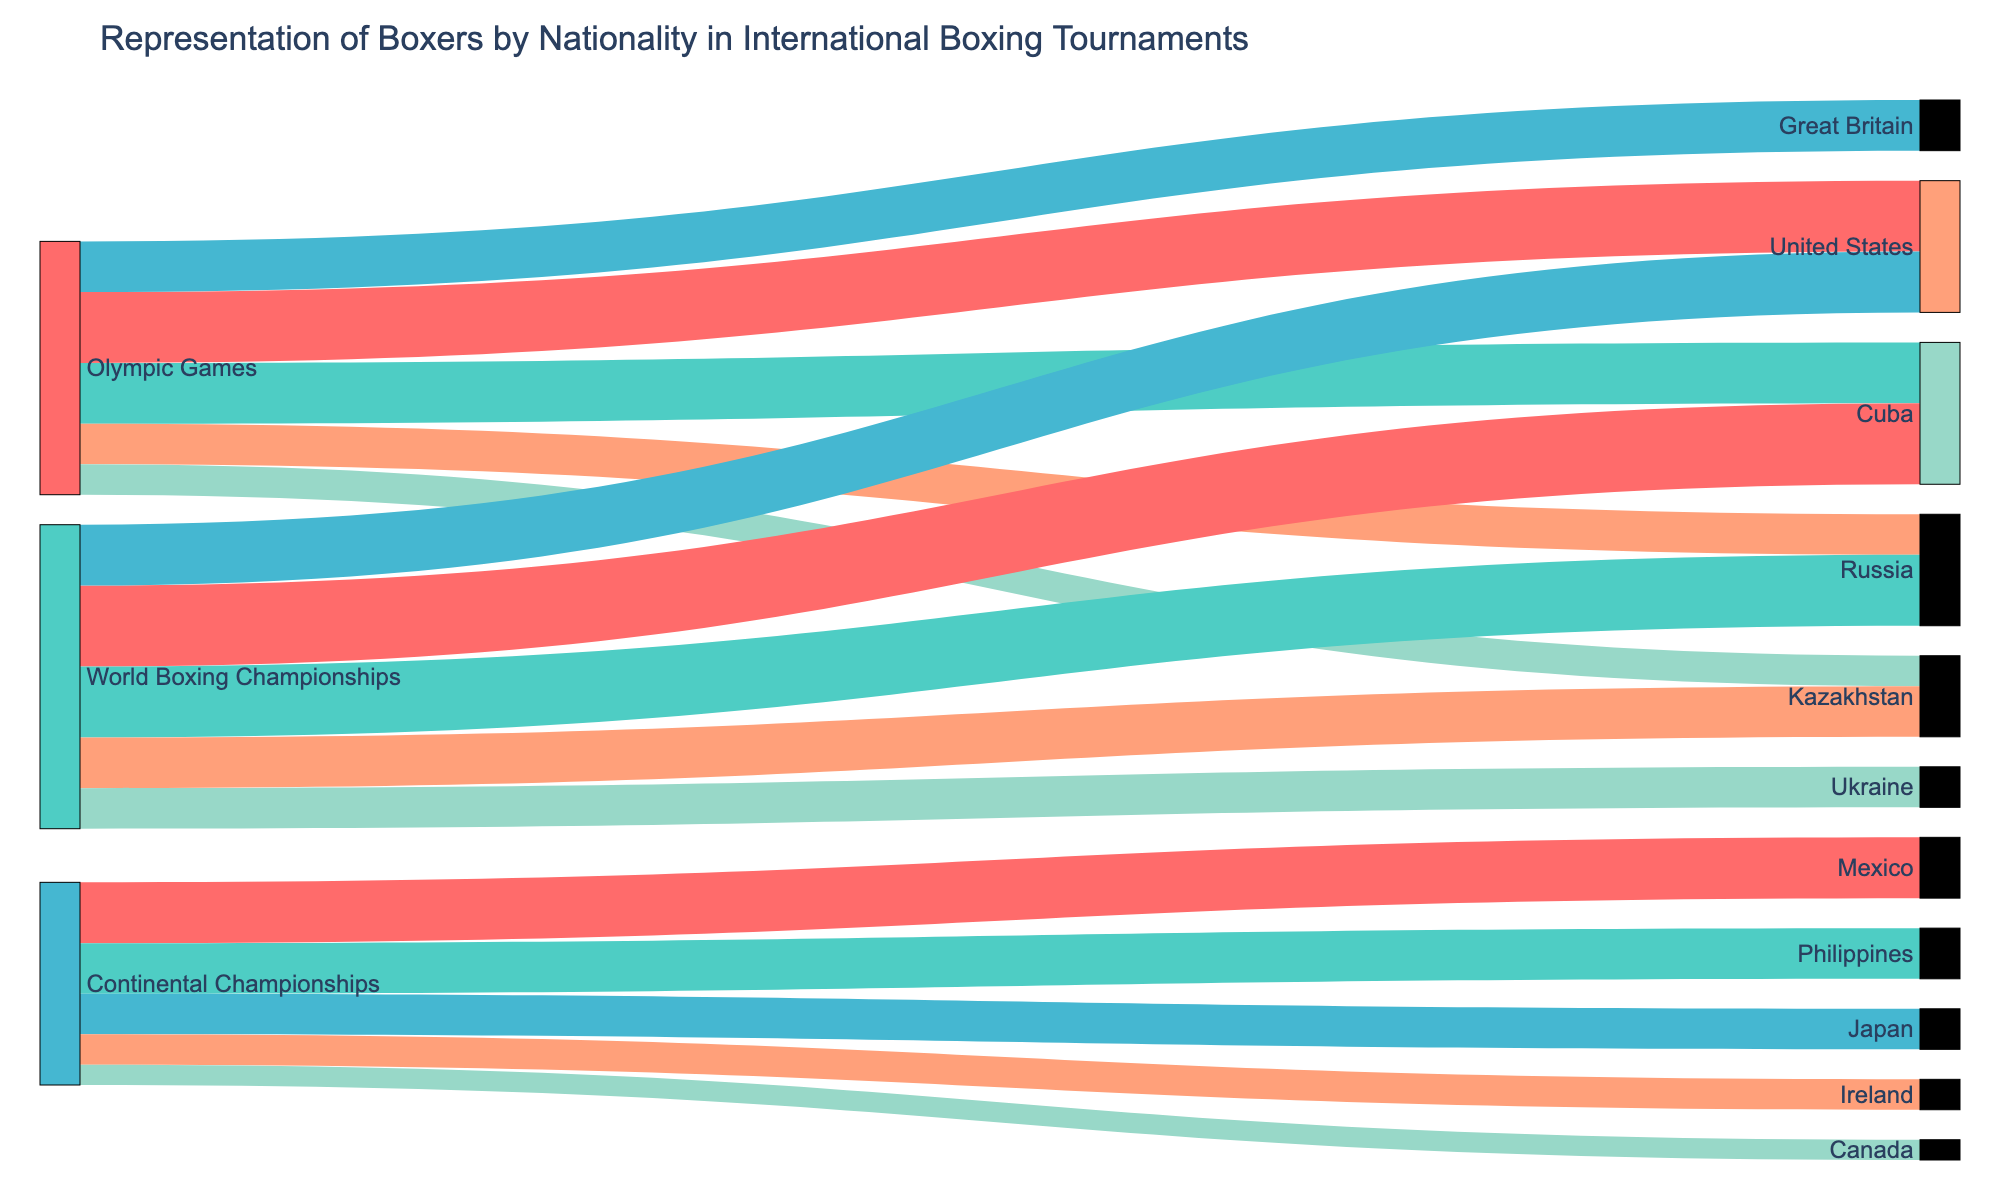what is the nationality with the highest count in the World Boxing Championships? Look for the World Boxing Championships source and find the nationality with the highest count. Cuba has the highest count of 40.
Answer: Cuba How many boxers from the United States participated in both the Olympic Games and World Boxing Championships together? Add the counts of United States boxers from both the Olympic Games and the World Boxing Championships. It's 35 (Olympic Games) + 30 (World Boxing Championships) = 65.
Answer: 65 Which tournament has the least number of participating boxers from Canada? Identify the count of participating boxers from Canada across all tournaments. The Continental Championships have 10 boxers from Canada, and since it is the only tournament with Canadian participants, it is also the one with the least.
Answer: Continental Championships Are there more boxers from Kazakhstan represented in the Olympic Games or the World Boxing Championships? Compare the counts for Kazakhstan in both tournaments: 15 in the Olympic Games and 25 in the World Boxing Championships. There are more in the World Boxing Championships.
Answer: World Boxing Championships What is the overall representation count for boxers from Russia across all tournaments? Sum the counts for Russia across all tournaments: 20 (Olympic Games) + 35 (World Boxing Championships) = 55.
Answer: 55 What is the most represented nationality in the Olympic Games? Identify the nationality with the highest count in the Olympic Games. The United States has the highest count of 35.
Answer: United States What are the top two nationalities with the highest number of boxers in the Continental Championships? Look at the counts for all nationalities in the Continental Championships and identify the top two: Mexico (30) and Philippines (25).
Answer: Mexico, Philippines How does the representation of Cuban boxers in the World Boxing Championships compare to the representation of American boxers? Compare the counts: Cuba has 40, whereas the United States has 30 in the World Boxing Championships. Cuba has a higher representation.
Answer: Cuba > United States What's the total number of nationalities represented in all the international boxing tournaments combined? Count the unique nationalities listed in the data. There are 10 unique nationalities.
Answer: 10 